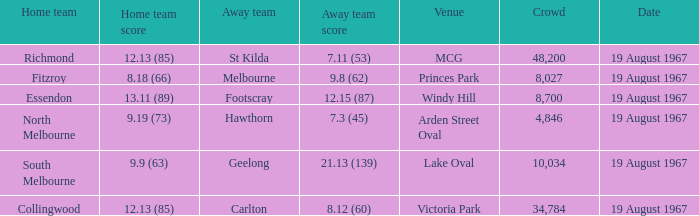What score did the home team achieve when playing at lake oval? 9.9 (63). 